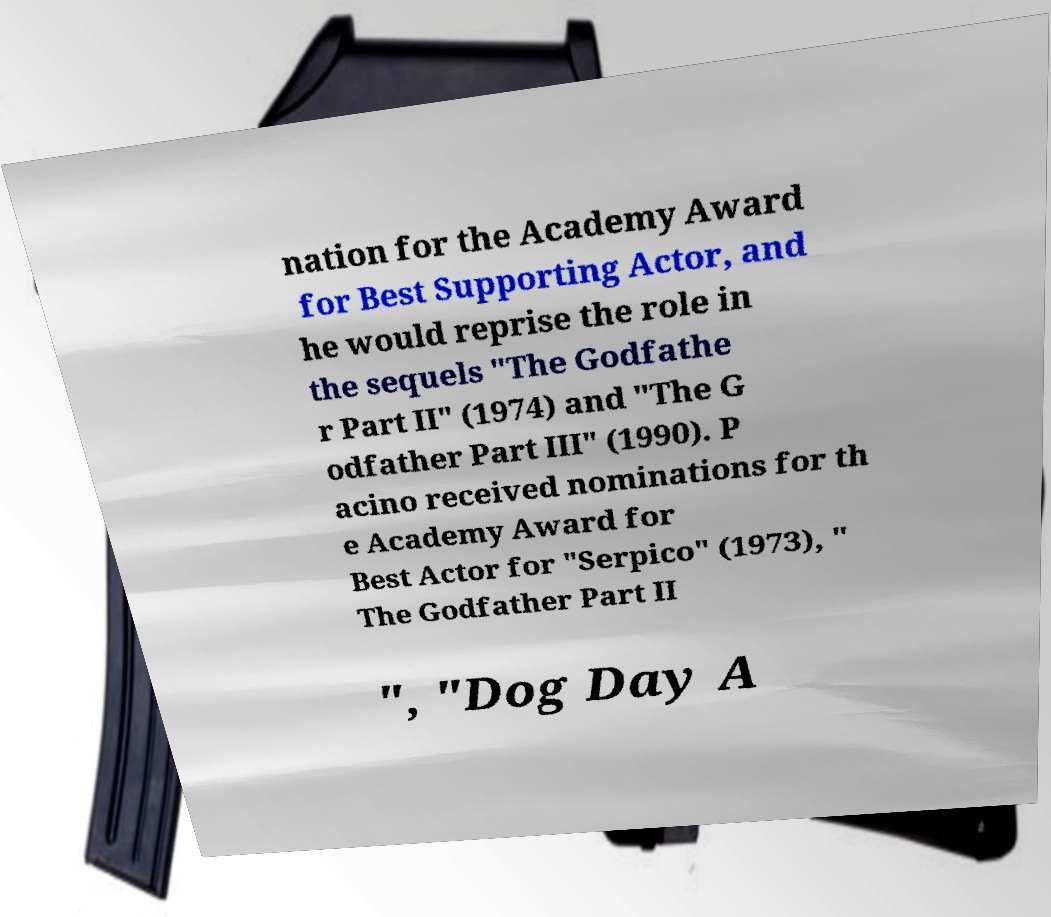I need the written content from this picture converted into text. Can you do that? nation for the Academy Award for Best Supporting Actor, and he would reprise the role in the sequels "The Godfathe r Part II" (1974) and "The G odfather Part III" (1990). P acino received nominations for th e Academy Award for Best Actor for "Serpico" (1973), " The Godfather Part II ", "Dog Day A 